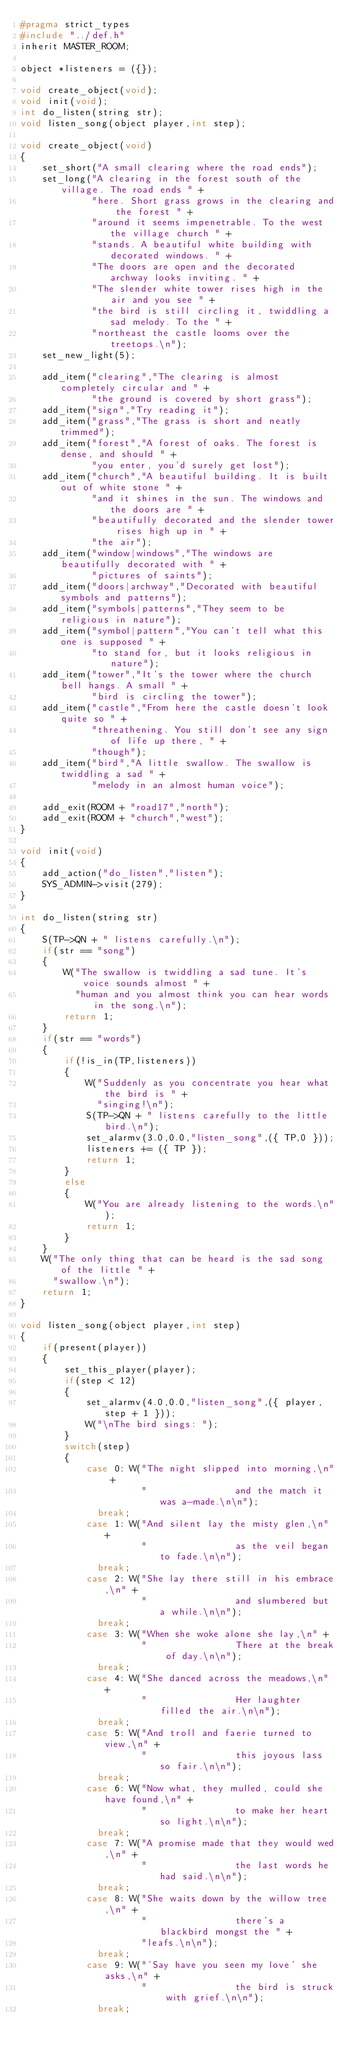<code> <loc_0><loc_0><loc_500><loc_500><_C_>#pragma strict_types
#include "../def.h"
inherit MASTER_ROOM;

object *listeners = ({});

void create_object(void);
void init(void);
int do_listen(string str);
void listen_song(object player,int step);

void create_object(void)
{
    set_short("A small clearing where the road ends");
    set_long("A clearing in the forest south of the village. The road ends " +
             "here. Short grass grows in the clearing and the forest " +
             "around it seems impenetrable. To the west the village church " +
             "stands. A beautiful white building with decorated windows. " +
             "The doors are open and the decorated archway looks inviting. " +
             "The slender white tower rises high in the air and you see " +
             "the bird is still circling it, twiddling a sad melody. To the " +
             "northeast the castle looms over the treetops.\n");
    set_new_light(5);

    add_item("clearing","The clearing is almost completely circular and " +
             "the ground is covered by short grass");
    add_item("sign","Try reading it");
    add_item("grass","The grass is short and neatly trimmed");
    add_item("forest","A forest of oaks. The forest is dense, and should " +
             "you enter, you'd surely get lost");
    add_item("church","A beautiful building. It is built out of white stone " +
             "and it shines in the sun. The windows and the doors are " +
             "beautifully decorated and the slender tower rises high up in " +
             "the air");
    add_item("window|windows","The windows are beautifully decorated with " +
             "pictures of saints");
    add_item("doors|archway","Decorated with beautiful symbols and patterns");
    add_item("symbols|patterns","They seem to be religious in nature");
    add_item("symbol|pattern","You can't tell what this one is supposed " +
             "to stand for, but it looks religious in nature");
    add_item("tower","It's the tower where the church bell hangs. A small " +
             "bird is circling the tower");
    add_item("castle","From here the castle doesn't look quite so " +
             "threathening. You still don't see any sign of life up there, " +
             "though");
    add_item("bird","A little swallow. The swallow is twiddling a sad " +
             "melody in an almost human voice");

    add_exit(ROOM + "road17","north");
    add_exit(ROOM + "church","west");
}

void init(void)
{
    add_action("do_listen","listen");
    SYS_ADMIN->visit(279);
}

int do_listen(string str)
{
    S(TP->QN + " listens carefully.\n");
    if(str == "song")
    {
        W("The swallow is twiddling a sad tune. It's voice sounds almost " +
          "human and you almost think you can hear words in the song.\n");
        return 1;
    }
    if(str == "words")
    {
        if(!is_in(TP,listeners))
        {
            W("Suddenly as you concentrate you hear what the bird is " +
              "singing!\n");
            S(TP->QN + " listens carefully to the little bird.\n");
            set_alarmv(3.0,0.0,"listen_song",({ TP,0 }));
            listeners += ({ TP });
            return 1;
        }
        else
        {
            W("You are already listening to the words.\n");
            return 1;
        }
    }
    W("The only thing that can be heard is the sad song of the little " +
      "swallow.\n");
    return 1;
}

void listen_song(object player,int step)
{
    if(present(player))
    {
        set_this_player(player);
        if(step < 12)
        {
            set_alarmv(4.0,0.0,"listen_song",({ player, step + 1 }));
            W("\nThe bird sings: ");
        }
        switch(step)
        {
            case 0: W("The night slipped into morning,\n" +
                      "                and the match it was a-made.\n\n");
              break;
            case 1: W("And silent lay the misty glen,\n" +
                      "                as the veil began to fade.\n\n");
              break;
            case 2: W("She lay there still in his embrace,\n" +
                      "                and slumbered but a while.\n\n");
              break;
            case 3: W("When she woke alone she lay,\n" +
                      "                There at the break of day.\n\n");
              break;
            case 4: W("She danced across the meadows,\n" +
                      "                Her laughter filled the air.\n\n");
              break;
            case 5: W("And troll and faerie turned to view,\n" +
                      "                this joyous lass so fair.\n\n");
              break;
            case 6: W("Now what, they mulled, could she have found,\n" +
                      "                to make her heart so light.\n\n");
              break;
            case 7: W("A promise made that they would wed,\n" +
                      "                the last words he had said.\n\n");
              break;
            case 8: W("She waits down by the willow tree,\n" +
                      "                there's a blackbird mongst the " +
                      "leafs.\n\n");
              break;
            case 9: W("'Say have you seen my love' she asks,\n" +
                      "                the bird is struck with grief.\n\n");
              break;</code> 